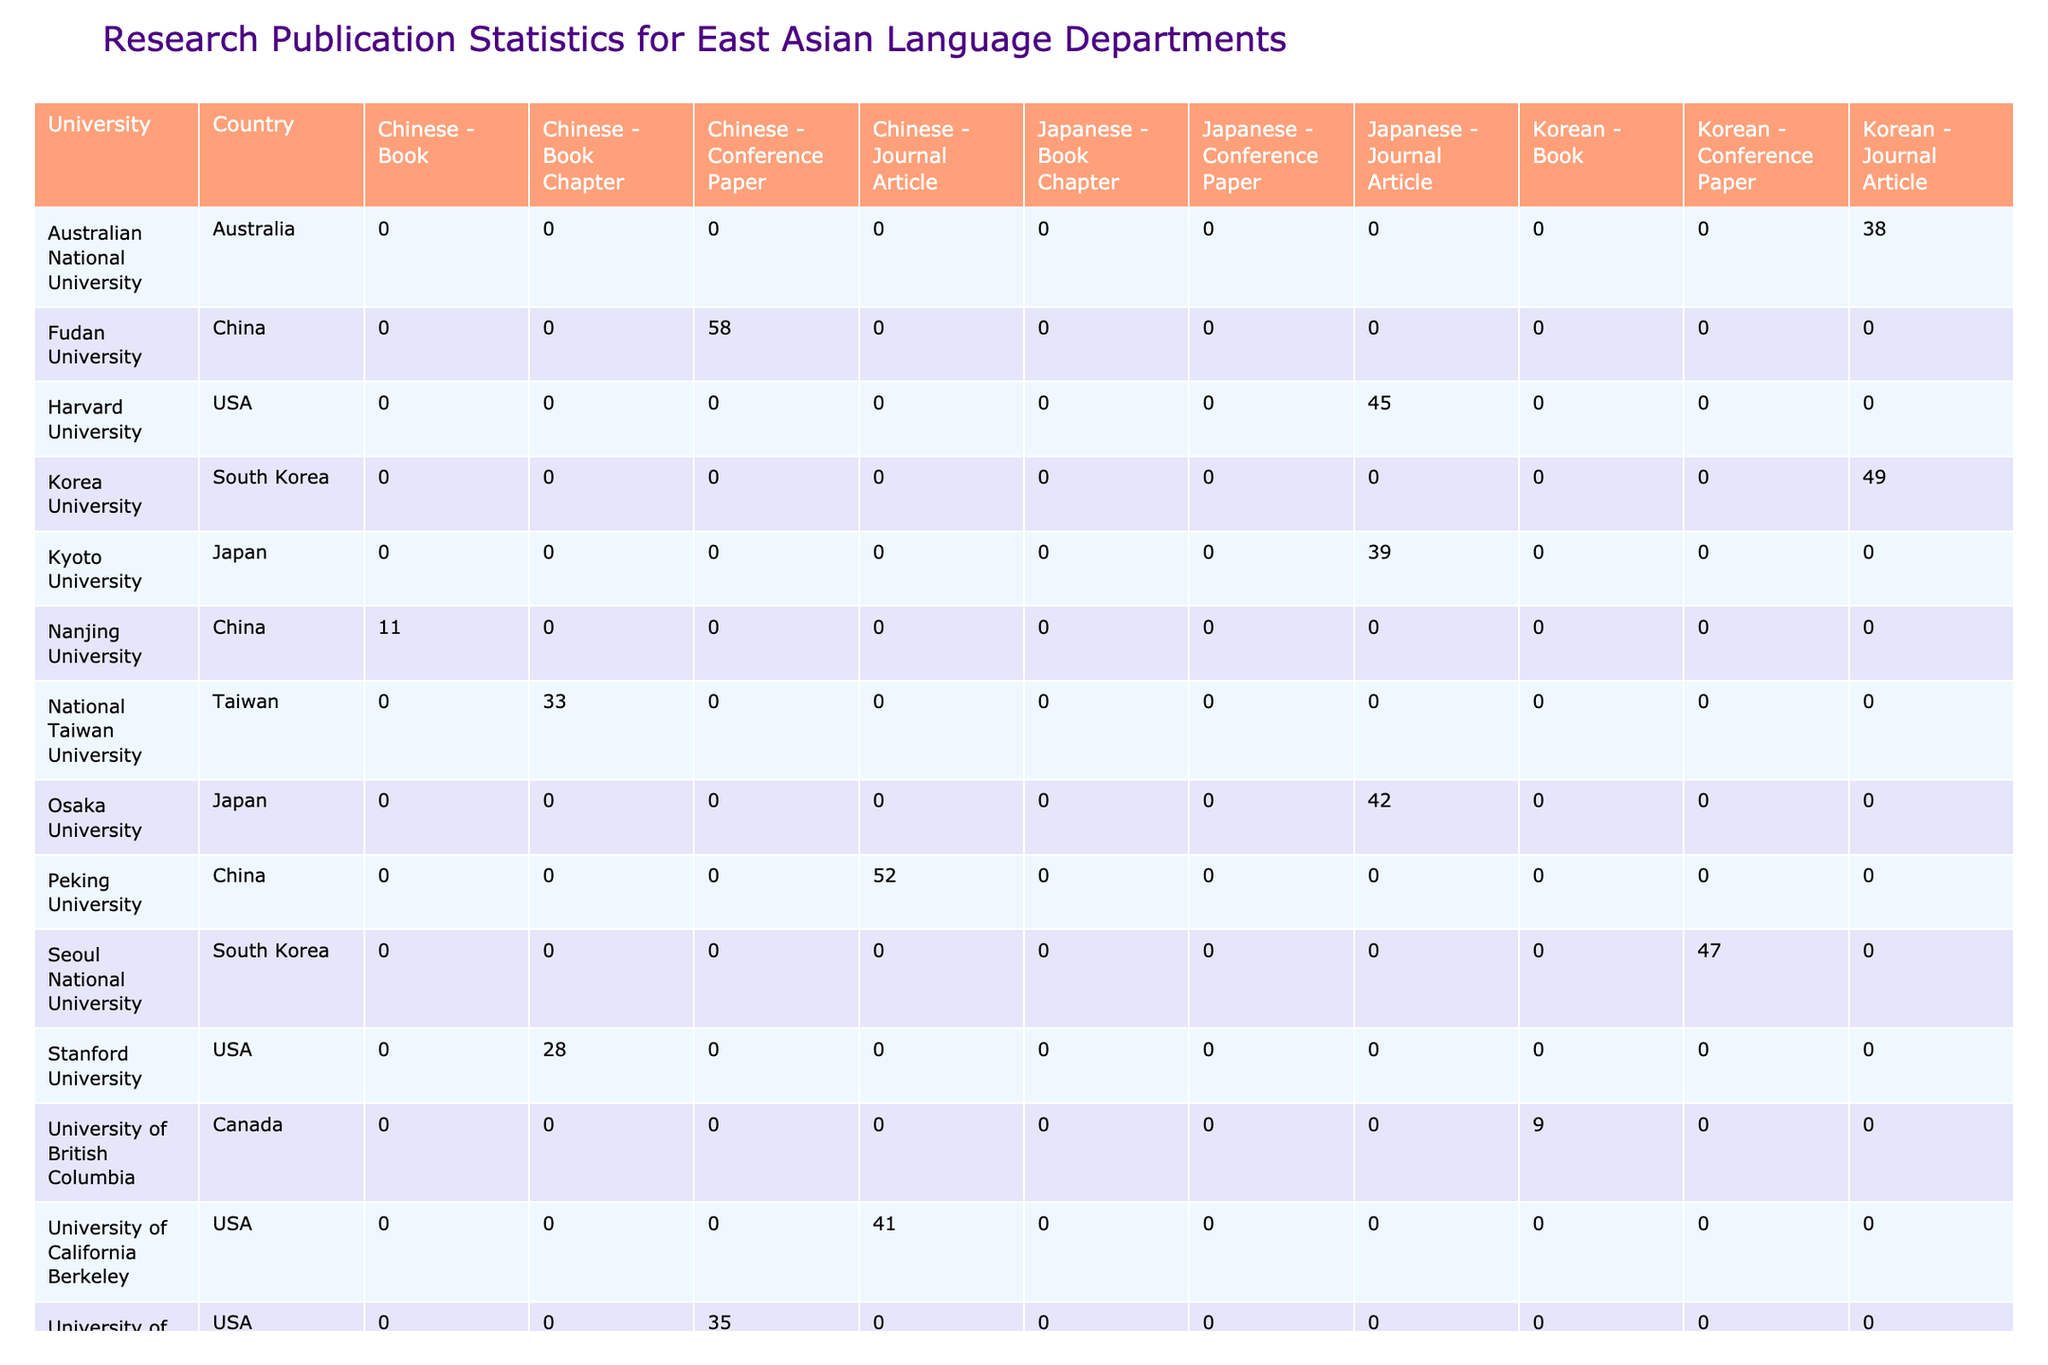What is the total number of journal articles published by Harvard University? Harvard University has published 45 journal articles in the year 2020. Therefore, the total is simply 45.
Answer: 45 How many total publications does the University of Tokyo have across all publication types? The University of Tokyo published 63 conference papers in 2021. Since it has no other publications listed, the total is 63.
Answer: 63 Which university published the highest number of Chinese journal articles? Peking University published 52 Chinese journal articles in 2018, which is the highest among the universities listed.
Answer: 52 Is there any university that published a book chapter in the Japanese language? Reviewing the table, Waseda University published a book chapter in Japanese. Thus, the fact is true.
Answer: Yes What is the average number of publications for Korean language departments? For Korean, we have the following publications: 12 (Yale), 47 (Seoul National), 49 (Korea), and 38 (Australian National). The total publications are 12 + 47 + 49 + 38 = 146, and since there are 4 entries, the average is 146/4 = 36.5.
Answer: 36.5 Which country has the most total publications in the Chinese language? Summarizing the data, we have: USA (41), China (52 + 58), and Taiwan (33). The total for China is 110 (52 + 58), which is more than any other country, making China the leader in total publications for Chinese.
Answer: China What is the difference in the number of citations between the University of California, Berkeley, and the University of London SOAS for their respective Chinese journal articles? The University of California Berkeley has 358 citations, while the University of London SOAS has 267 citations. The difference is 358 - 267 = 91.
Answer: 91 Did any university publish more than 40 publications in the Korean language? Evaluating the Korean publications, Korea University with 49 publications and Seoul National University with 47 published more than 40. Thus, the answer is true.
Answer: Yes Which publication type had the lowest total number of publications across all universities for the Japanese language? Adding the totals, we find: Harvard (0 for Book Chapters), Kyoto (0 for Book Chapters), Waseda (26 for Book Chapters), and Osaka (0 for Book Chapters). The total for Book Chapters in Japanese is 0, making it the lowest publication type for Japanese.
Answer: Book Chapter 